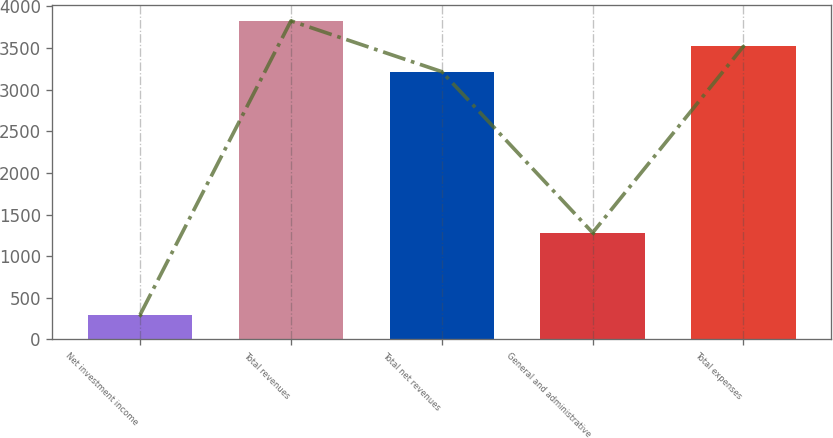Convert chart to OTSL. <chart><loc_0><loc_0><loc_500><loc_500><bar_chart><fcel>Net investment income<fcel>Total revenues<fcel>Total net revenues<fcel>General and administrative<fcel>Total expenses<nl><fcel>297<fcel>3826.4<fcel>3216<fcel>1282<fcel>3521.2<nl></chart> 